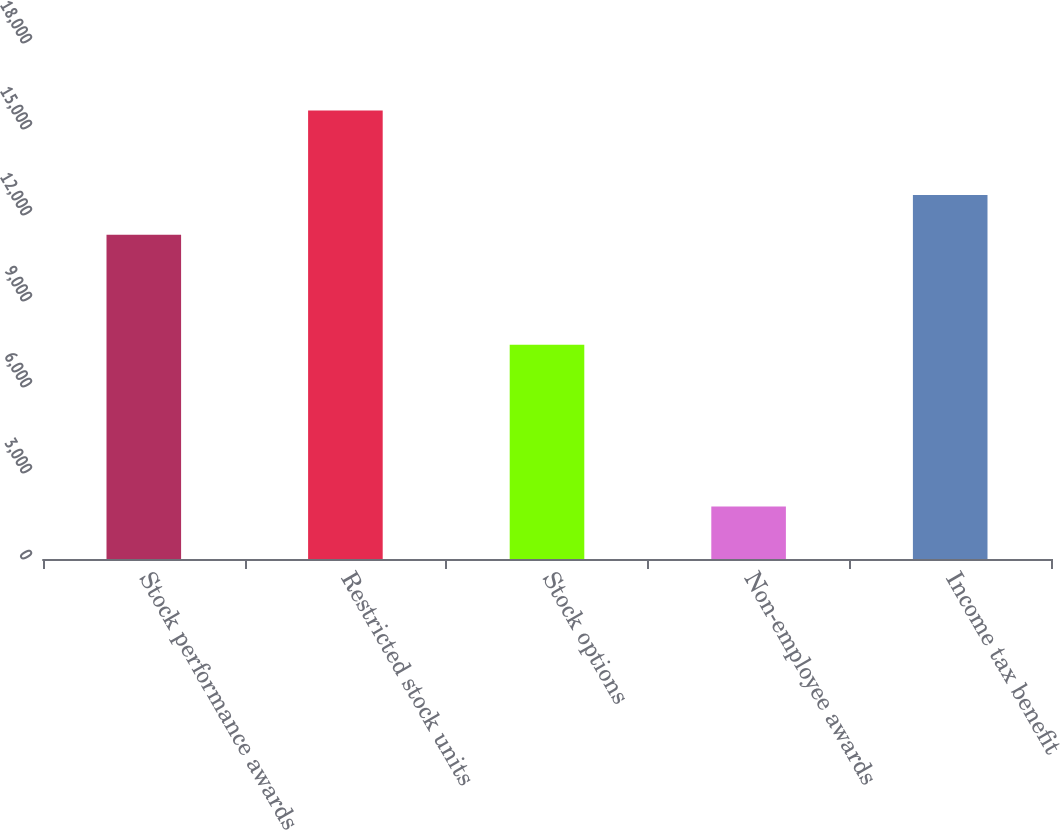<chart> <loc_0><loc_0><loc_500><loc_500><bar_chart><fcel>Stock performance awards<fcel>Restricted stock units<fcel>Stock options<fcel>Non-employee awards<fcel>Income tax benefit<nl><fcel>11315<fcel>15643<fcel>7473<fcel>1834<fcel>12695.9<nl></chart> 